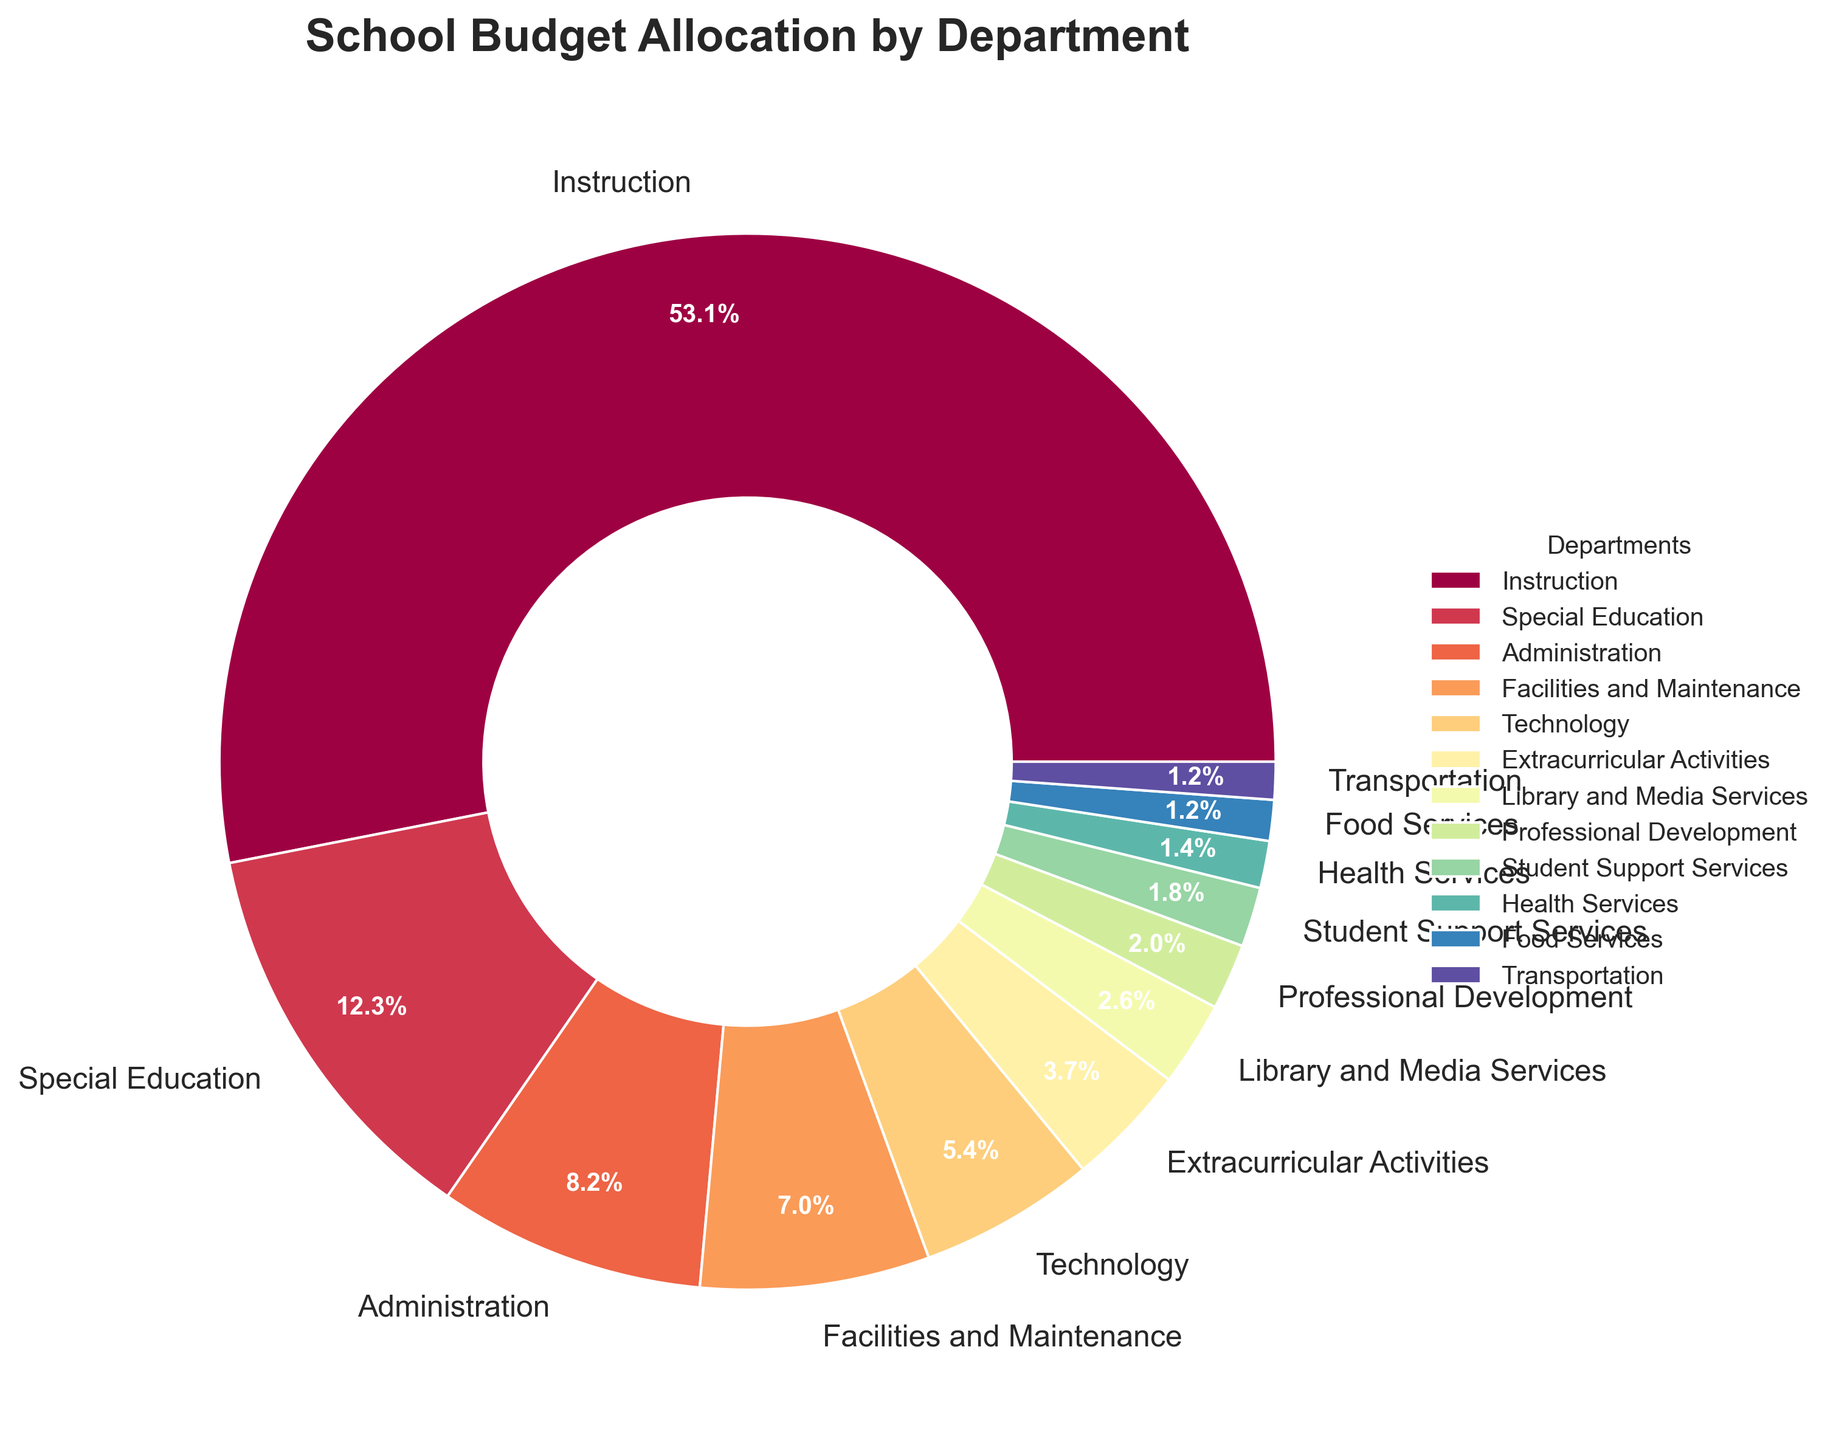Which department has the highest budget allocation? By looking at the pie chart, we can see that the "Instruction" department has the largest section, labeled with "55.2%".
Answer: Instruction What percentage of the budget is allocated to Administration and Facilities and Maintenance combined? From the pie chart, we see that Administration is 8.5% and Facilities and Maintenance is 7.3%. Adding them together: 8.5 + 7.3 = 15.8%.
Answer: 15.8% Which has a larger budget allocation: Technology or Extracurricular Activities? We compare the two sections in the pie chart, Technology (5.6%) is larger than Extracurricular Activities (3.9%).
Answer: Technology How much more budget allocation does Instruction receive compared to Special Education? Looking at the chart, Instruction has 55.2% and Special Education has 12.8%. Subtracting the latter from the former: 55.2 - 12.8 = 42.4%.
Answer: 42.4% What is the total budget allocation of Library and Media Services, Professional Development, and Student Support Services combined? The percentages are 2.7% for Library and Media Services, 2.1% for Professional Development, and 1.9% for Student Support Services. Summing them up: 2.7 + 2.1 + 1.9 = 6.7%.
Answer: 6.7% Which department has the smallest budget allocation? By observing the pie chart, we see the smallest slice is for the "Transportation" department, labeled with "1.2%".
Answer: Transportation Is the combined budget for Health Services and Food Services greater or smaller than that of Technology? Health Services is 1.5% and Food Services is 1.3%, giving a total of 1.5 + 1.3 = 2.8%. Comparing with Technology's 5.6%, 2.8% is smaller.
Answer: Smaller What is the budget difference between Facilities and Maintenance and Transportation? Facilities and Maintenance has 7.3% and Transportation has 1.2%. Subtracting the latter from the former: 7.3 - 1.2 = 6.1%.
Answer: 6.1% Which departments have budget allocations less than 3%? The pie chart shows Library and Media Services (2.7%), Professional Development (2.1%), Student Support Services (1.9%), Health Services (1.5%), Food Services (1.3%), and Transportation (1.2%) each have less than 3%.
Answer: Library and Media Services, Professional Development, Student Support Services, Health Services, Food Services, Transportation How many departments have a budget allocation between 5% and 10%? The pie chart shows Technology (5.6%), Facilities and Maintenance (7.3%), and Administration (8.5%) in this range. This counts to 3 departments.
Answer: 3 